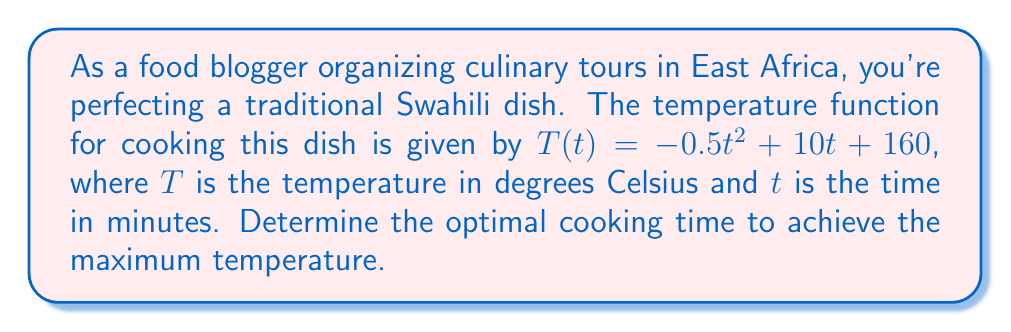Could you help me with this problem? To find the optimal cooking time, we need to determine when the temperature function reaches its maximum value. This occurs when the derivative of the function equals zero.

1) First, let's find the derivative of $T(t)$:
   $$\frac{dT}{dt} = -t + 10$$

2) Set the derivative equal to zero and solve for $t$:
   $$-t + 10 = 0$$
   $$-t = -10$$
   $$t = 10$$

3) To confirm this is a maximum (not a minimum), we can check the second derivative:
   $$\frac{d^2T}{dt^2} = -1$$
   Since this is negative, we confirm that $t = 10$ gives a maximum.

4) Therefore, the optimal cooking time is 10 minutes.

5) We can calculate the maximum temperature reached:
   $$T(10) = -0.5(10)^2 + 10(10) + 160 = -50 + 100 + 160 = 210°C$$
Answer: 10 minutes 